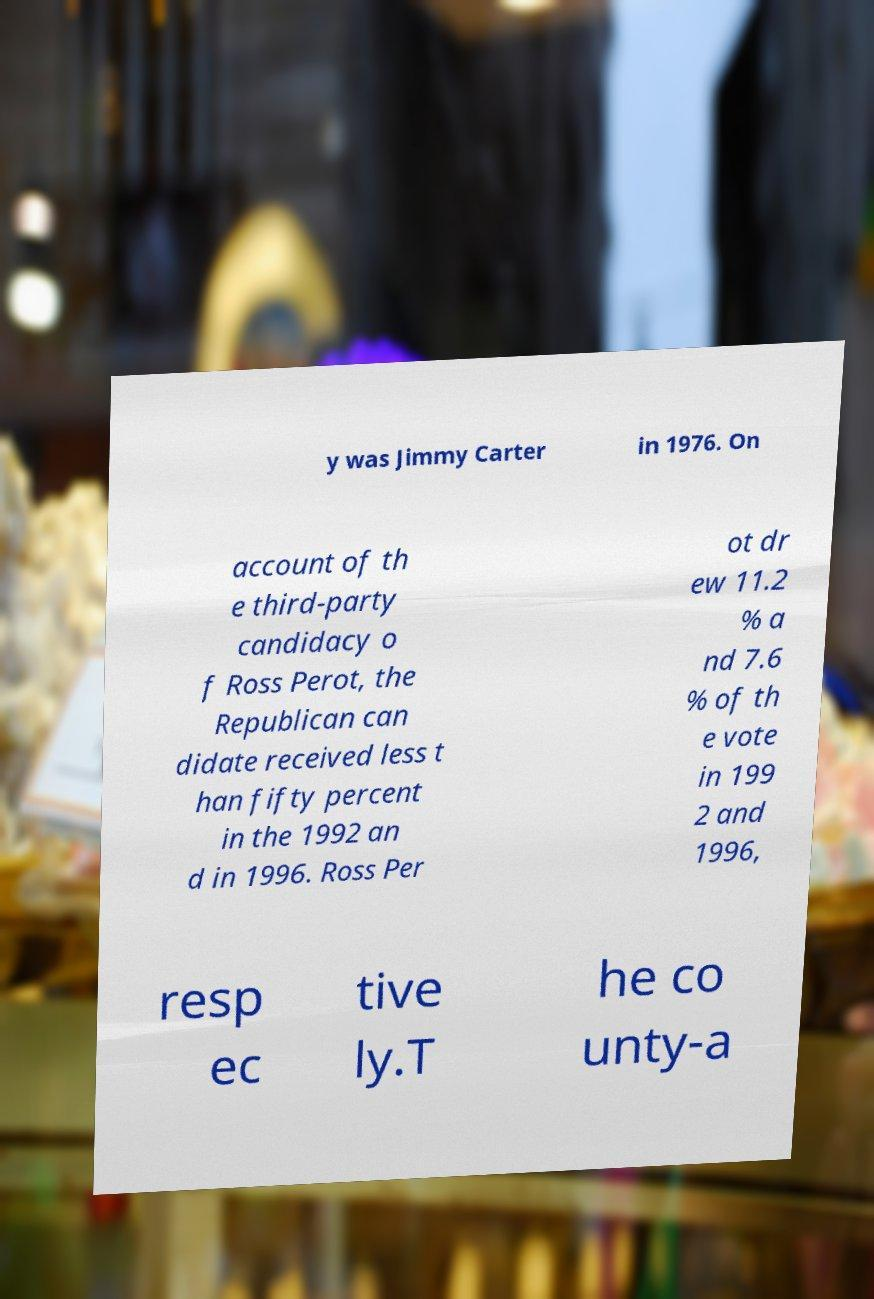Can you read and provide the text displayed in the image?This photo seems to have some interesting text. Can you extract and type it out for me? y was Jimmy Carter in 1976. On account of th e third-party candidacy o f Ross Perot, the Republican can didate received less t han fifty percent in the 1992 an d in 1996. Ross Per ot dr ew 11.2 % a nd 7.6 % of th e vote in 199 2 and 1996, resp ec tive ly.T he co unty-a 